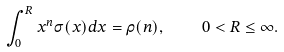<formula> <loc_0><loc_0><loc_500><loc_500>\int _ { 0 } ^ { R } x ^ { n } \sigma ( x ) d x = \rho ( n ) , \quad 0 < R \leq \infty .</formula> 